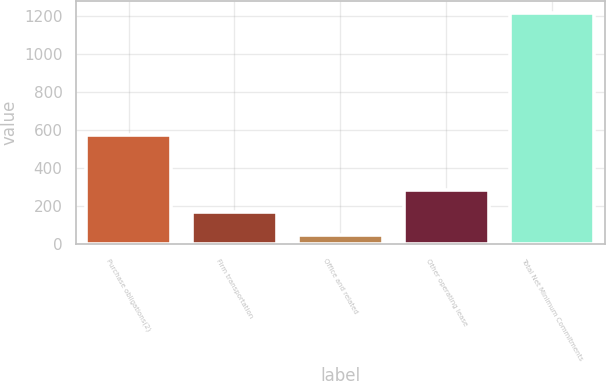Convert chart to OTSL. <chart><loc_0><loc_0><loc_500><loc_500><bar_chart><fcel>Purchase obligations(2)<fcel>Firm transportation<fcel>Office and related<fcel>Other operating lease<fcel>Total Net Minimum Commitments<nl><fcel>578<fcel>168.7<fcel>52<fcel>285.4<fcel>1219<nl></chart> 